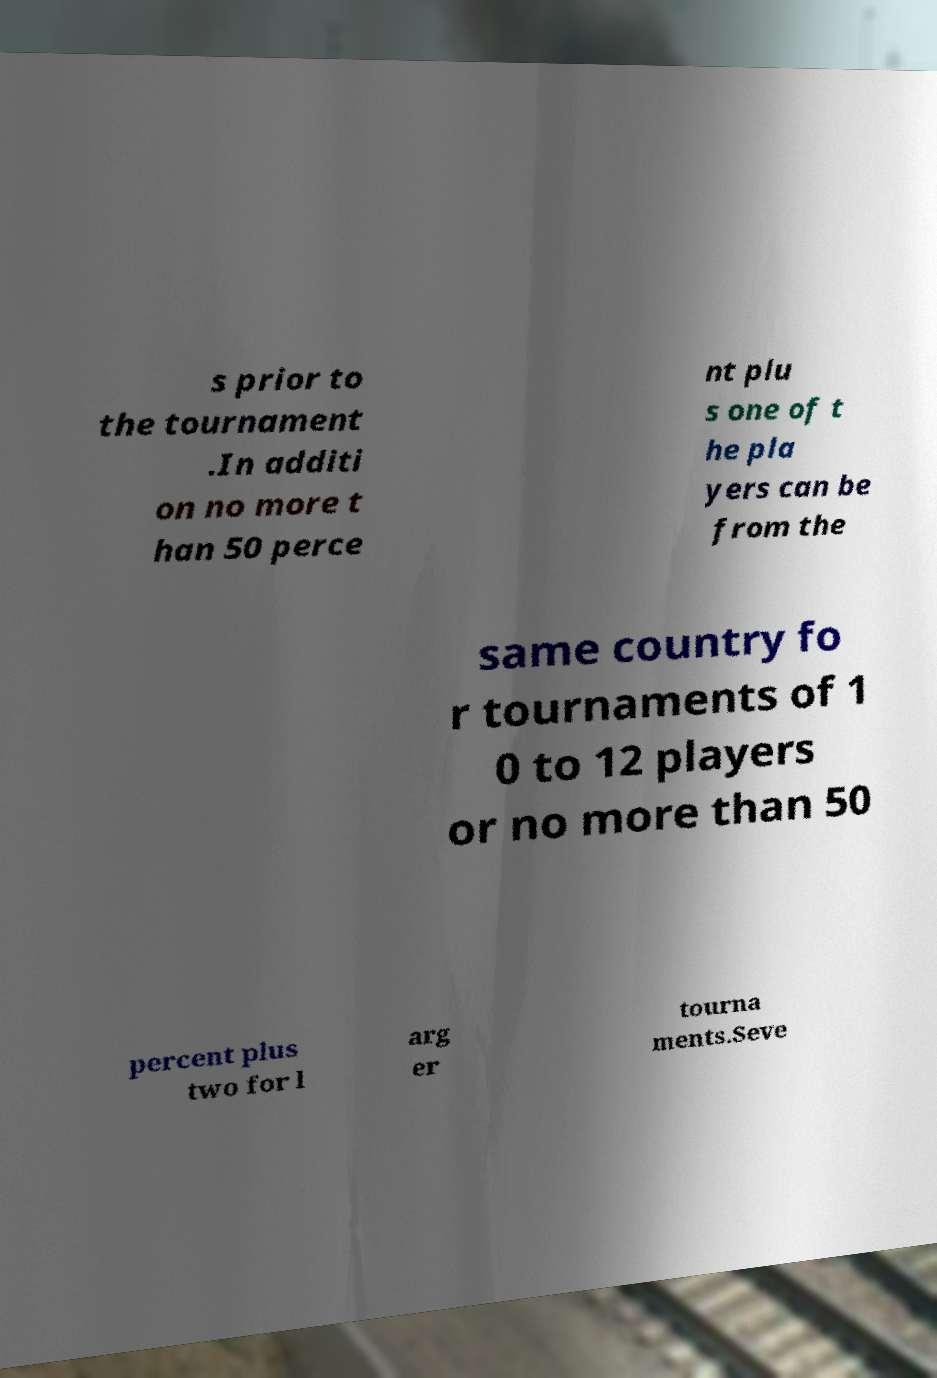Can you accurately transcribe the text from the provided image for me? s prior to the tournament .In additi on no more t han 50 perce nt plu s one of t he pla yers can be from the same country fo r tournaments of 1 0 to 12 players or no more than 50 percent plus two for l arg er tourna ments.Seve 